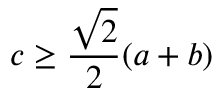Convert formula to latex. <formula><loc_0><loc_0><loc_500><loc_500>c \geq { \frac { \sqrt { 2 } } { 2 } } ( a + b )</formula> 